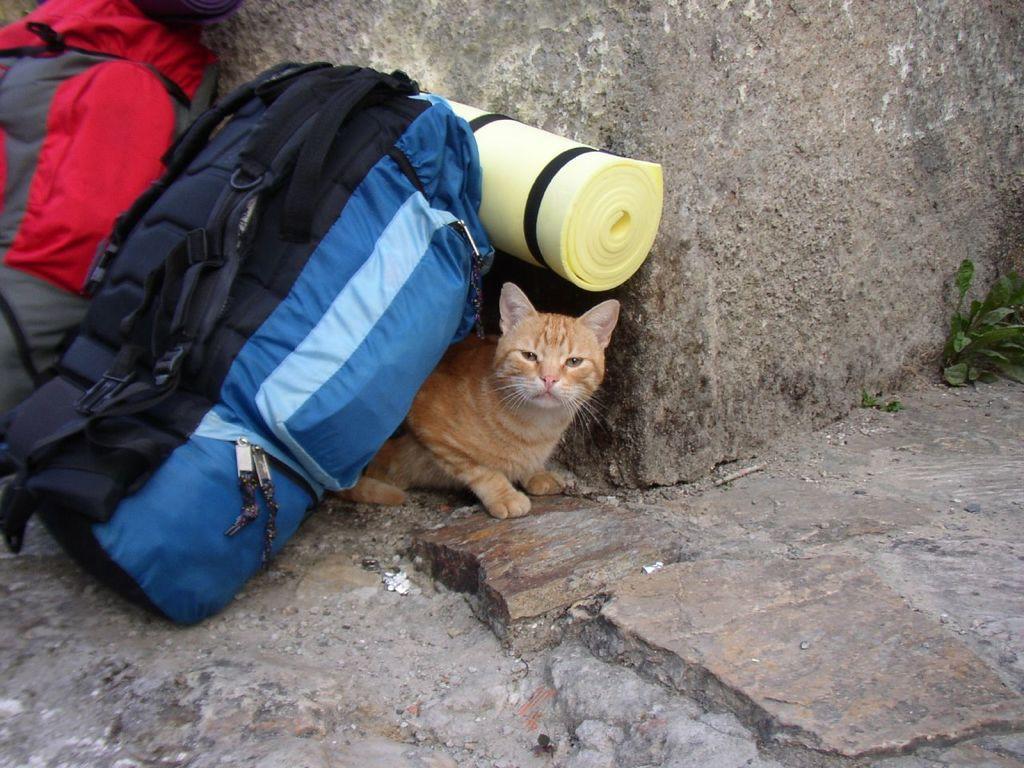Can you describe this image briefly? In this picture we can see a cat and backpacks on the ground. On top of the backpack, there is an object. At the top of the image, there is a rock. On the right side of the image, there is a plant. 